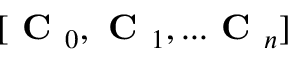Convert formula to latex. <formula><loc_0><loc_0><loc_500><loc_500>[ C _ { 0 } , C _ { 1 } , \dots C _ { n } ]</formula> 